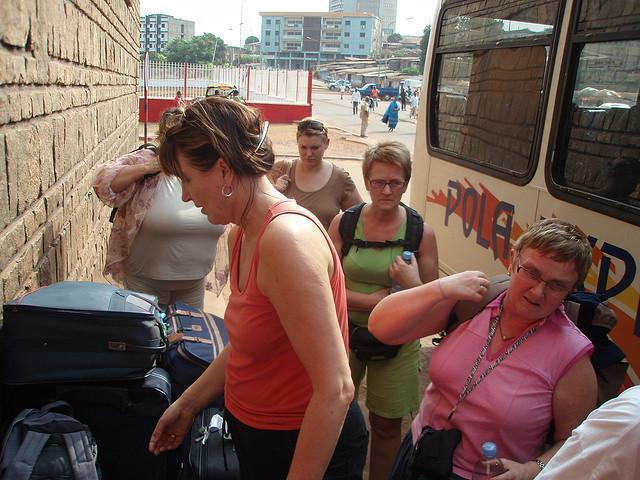What are the buildings in the background likely used for?
Pick the right solution, then justify: 'Answer: answer
Rationale: rationale.'
Options: Offices, private dwellings, shops, schools. Answer: private dwellings.
Rationale: The blue three story and tan four story buildings appear to be apartment buildings. 